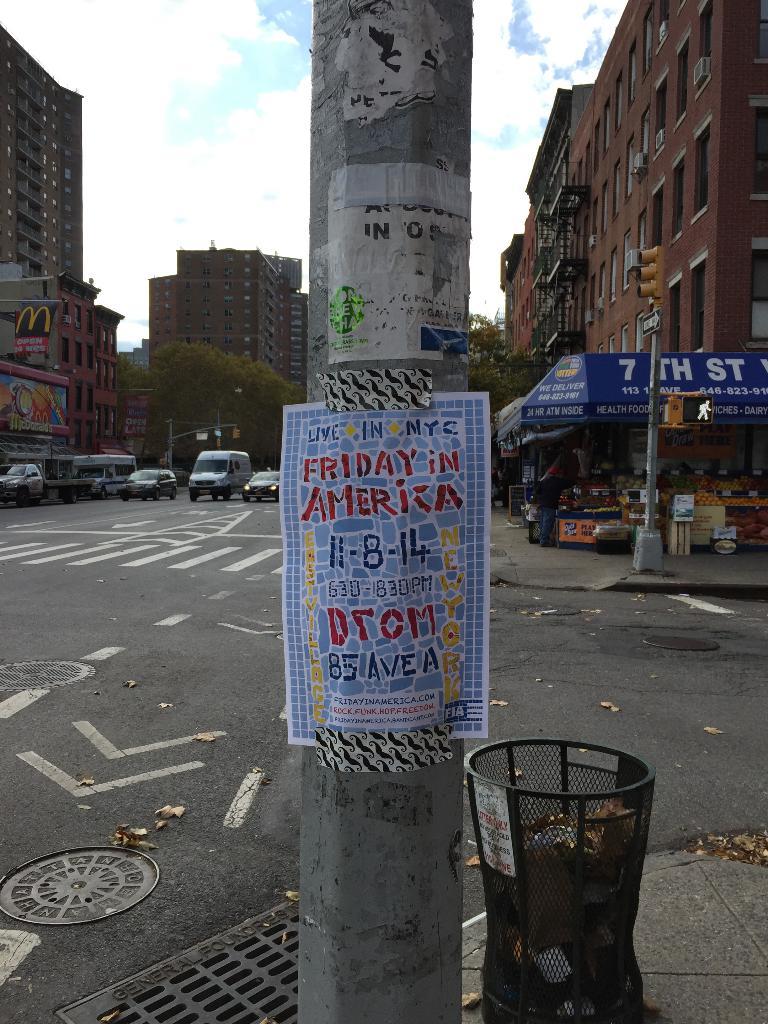The date on the poster is?
Keep it short and to the point. 11-8-14. 